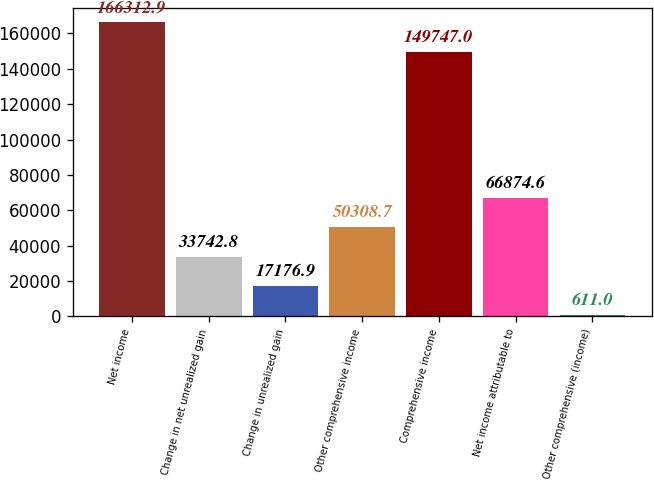Convert chart to OTSL. <chart><loc_0><loc_0><loc_500><loc_500><bar_chart><fcel>Net income<fcel>Change in net unrealized gain<fcel>Change in unrealized gain<fcel>Other comprehensive income<fcel>Comprehensive income<fcel>Net income attributable to<fcel>Other comprehensive (income)<nl><fcel>166313<fcel>33742.8<fcel>17176.9<fcel>50308.7<fcel>149747<fcel>66874.6<fcel>611<nl></chart> 